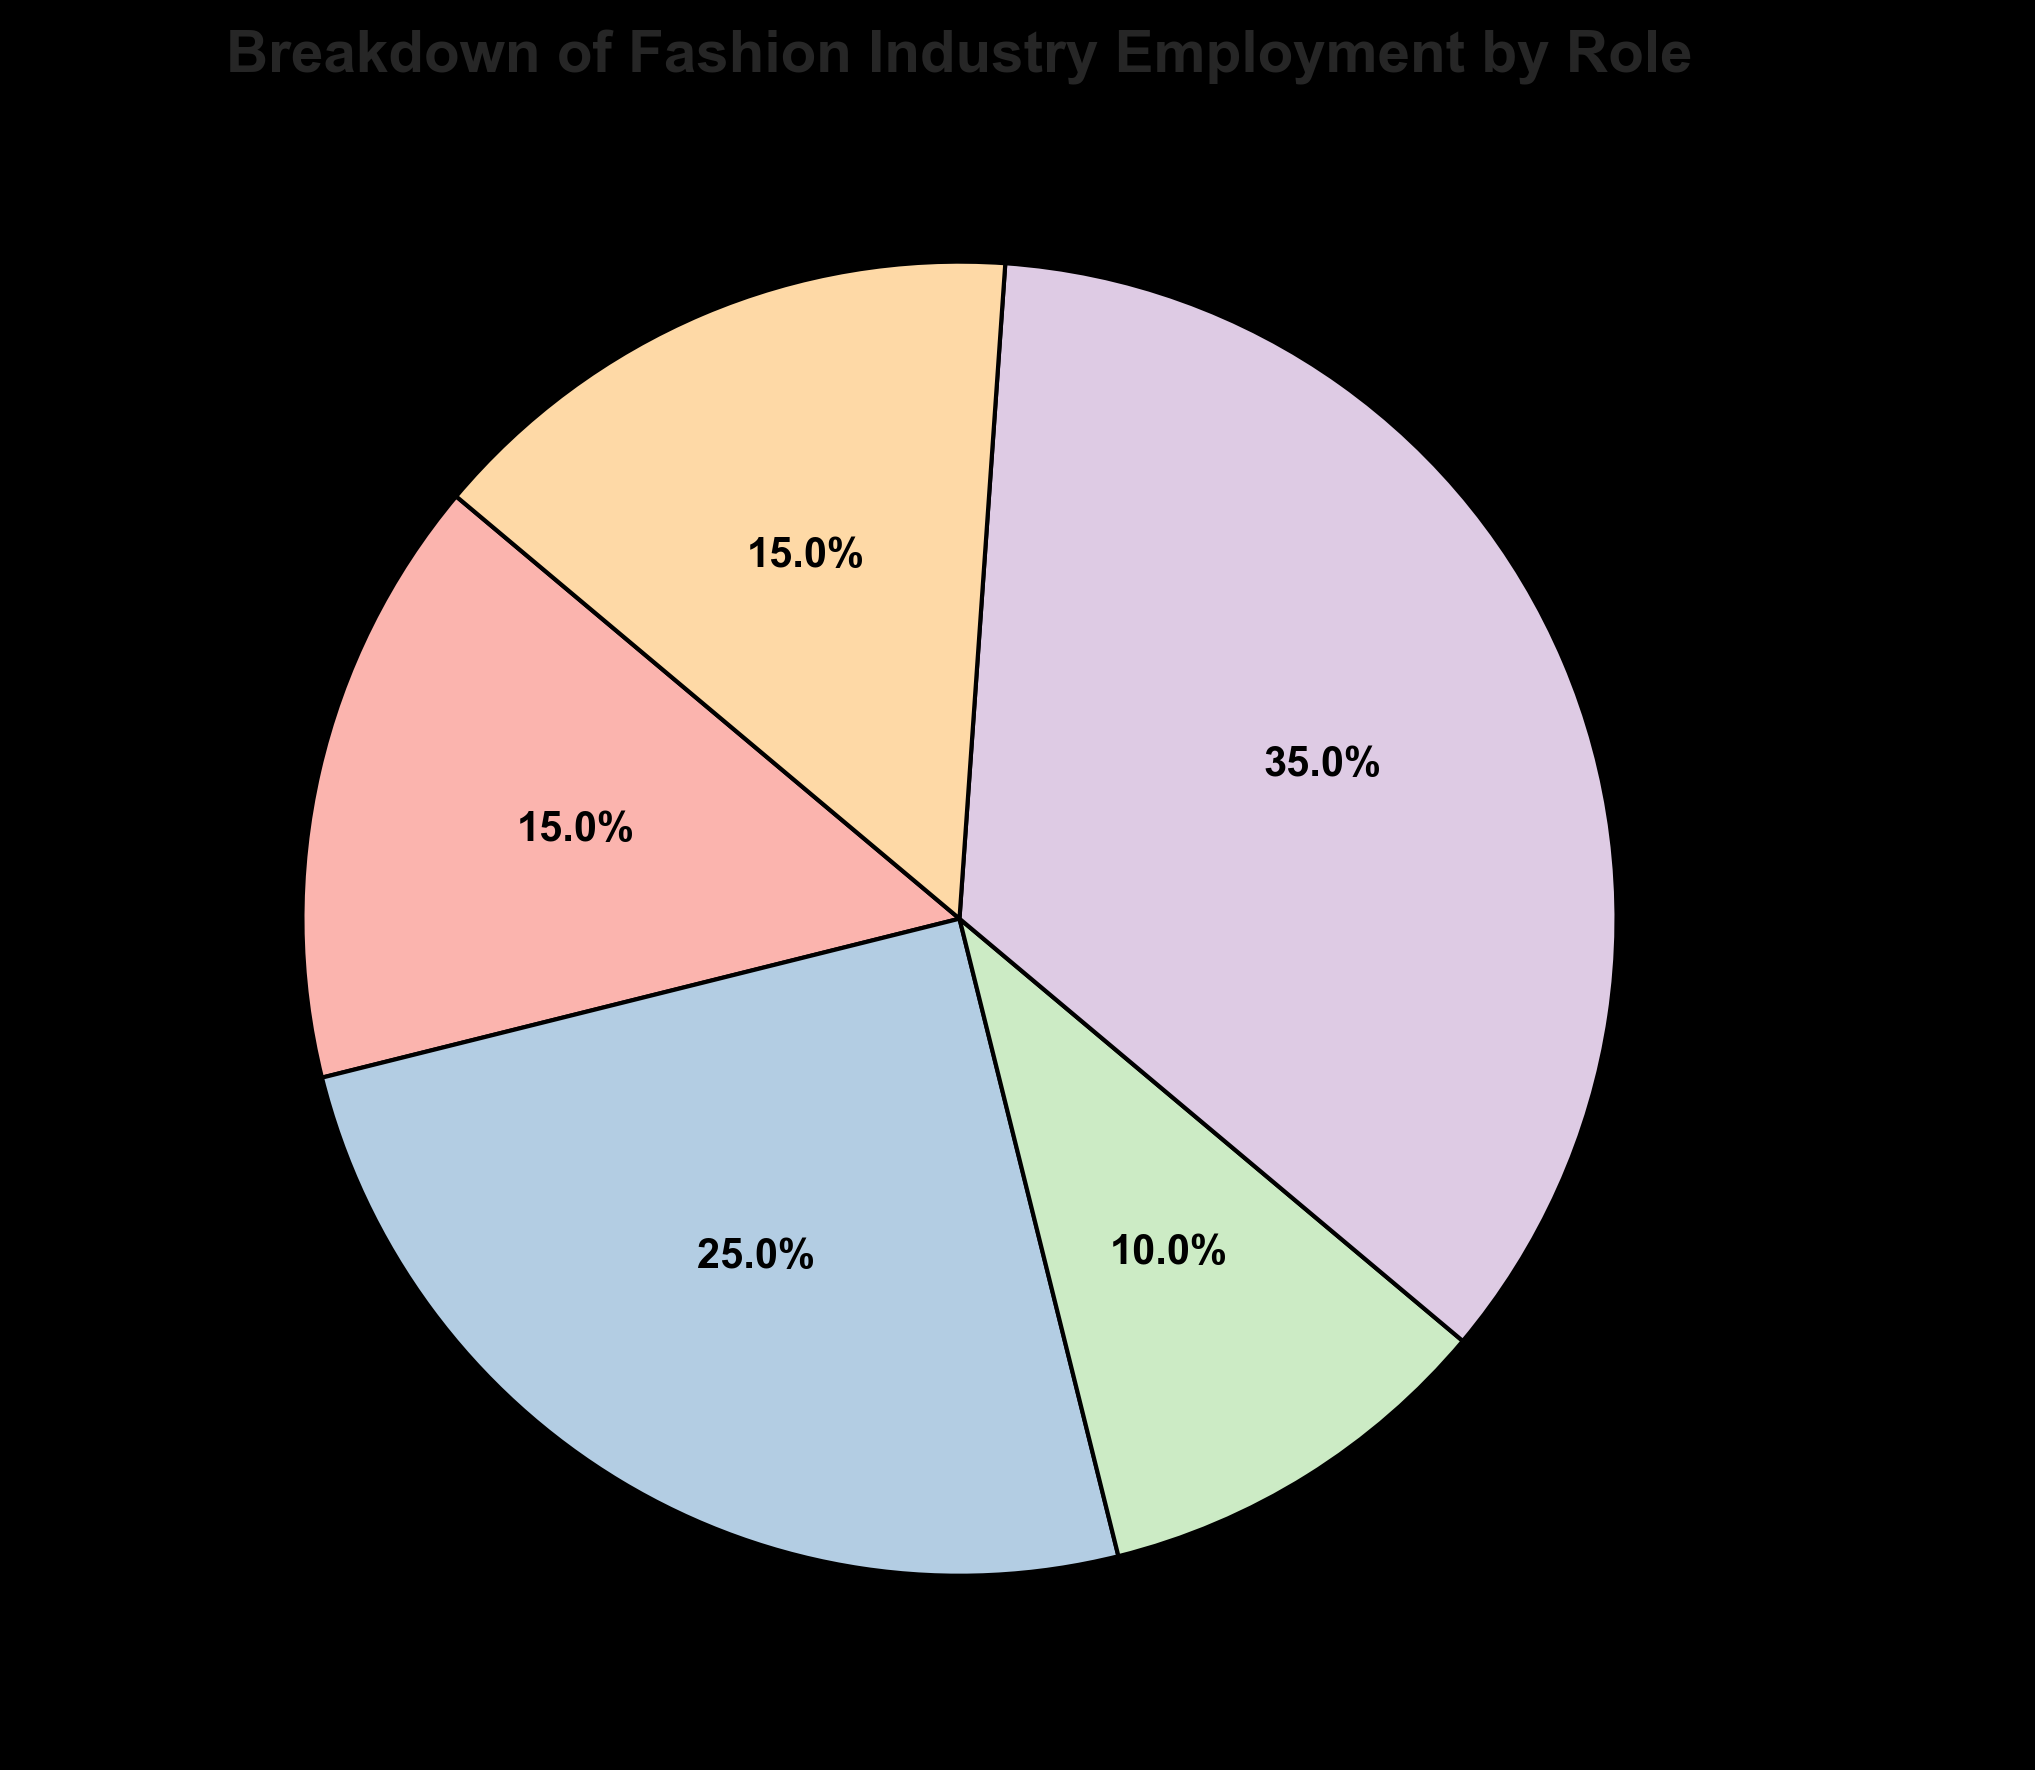Which role has the highest employment percentage? By looking at the pie chart, we can identify the segment with the largest size. In this case, the 'Retail Associates' segment is the largest.
Answer: Retail Associates Which two roles have the same employment percentage? From the pie chart, we can observe the segments labeled with percentages. Both 'Designers' and 'Others' are labeled with 15%.
Answer: Designers and Others What is the total employment percentage of Seamstresses and Marketers? By summing the percentages of 'Seamstresses' (25%) and 'Marketers' (10%), we get 25% + 10% = 35%.
Answer: 35% Which role has half the employment percentage of Retail Associates? The 'Retail Associates' have 35%. Half of 35% is 17.5%, which does not directly match any role. The role closest is 'Seamstresses' with 25%, but it is not half.
Answer: None What is the difference in employment percentage between the role with the highest employment and the role with the lowest employment? 'Retail Associates' have the highest at 35%, and 'Marketers' have the lowest at 10%. The difference is 35% - 10% = 25%.
Answer: 25% Which roles together make up 50% of the employment? By summing the percentages, 'Seamstresses' (25%) and 'Retail Associates' (35%) together make 60%, so we need a combination that sums to 50%. 'Designers' (15%) + 'Seamstresses' (25%) + 'Marketers' (10%) = 50%.
Answer: Designers, Seamstresses, and Marketers What is the average employment percentage of all roles? Summing the percentages of all roles: 15% + 25% + 10% + 35% + 15% = 100%. Dividing by the number of roles (5), we get 100% / 5 = 20%.
Answer: 20% Which role's segment is colored blue in the pie chart? Observing the pie chart, the 'Retail Associates' segment is colored blue.
Answer: Retail Associates 